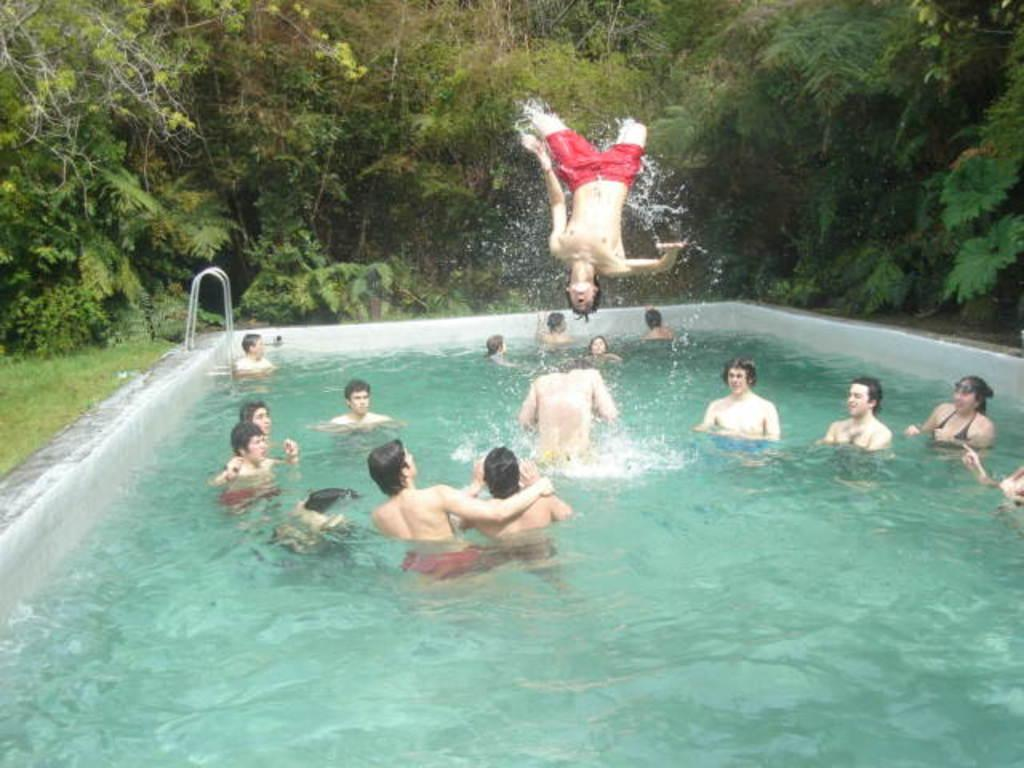What is the main activity taking place in the image? There are many people in the swimming pool, and one person is jumping in the swimming pool. What can be seen in the background of the image? There are trees and grass visible in the image. What type of thought is being expressed by the brick in the image? There is no brick present in the image, and therefore no thoughts can be attributed to it. 